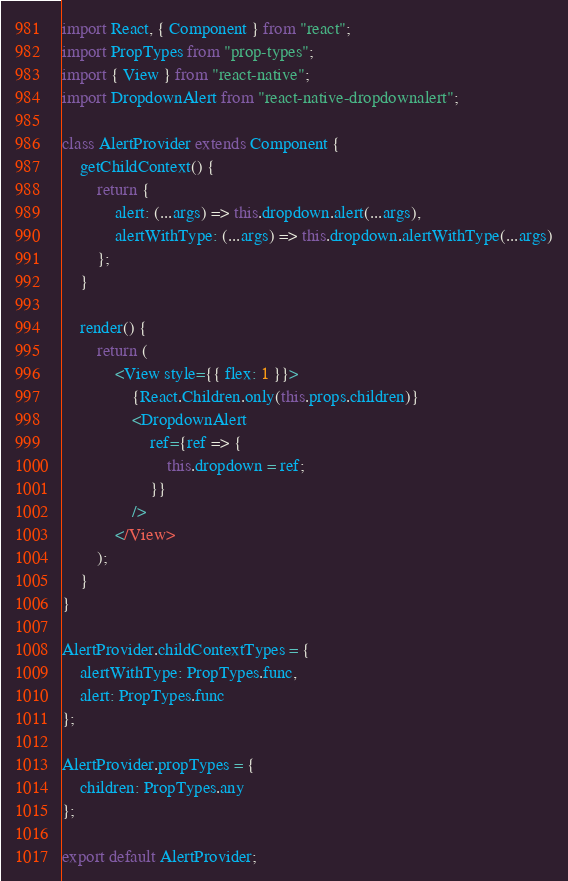Convert code to text. <code><loc_0><loc_0><loc_500><loc_500><_JavaScript_>import React, { Component } from "react";
import PropTypes from "prop-types";
import { View } from "react-native";
import DropdownAlert from "react-native-dropdownalert";

class AlertProvider extends Component {
	getChildContext() {
		return {
			alert: (...args) => this.dropdown.alert(...args),
			alertWithType: (...args) => this.dropdown.alertWithType(...args)
		};
	}

	render() {
		return (
			<View style={{ flex: 1 }}>
				{React.Children.only(this.props.children)}
				<DropdownAlert
					ref={ref => {
						this.dropdown = ref;
					}}
				/>
			</View>
		);
	}
}

AlertProvider.childContextTypes = {
	alertWithType: PropTypes.func,
	alert: PropTypes.func
};

AlertProvider.propTypes = {
	children: PropTypes.any
};

export default AlertProvider;
</code> 